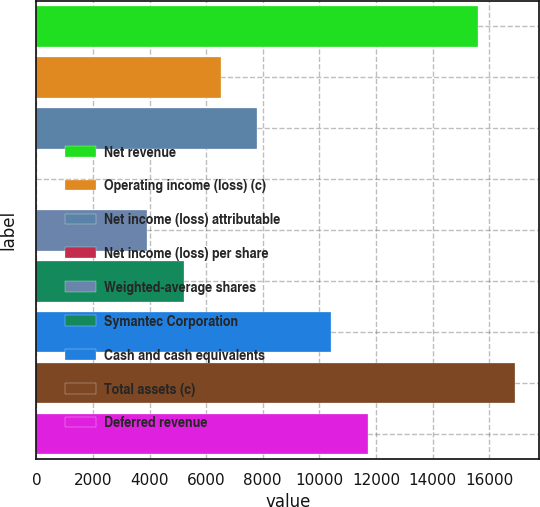Convert chart to OTSL. <chart><loc_0><loc_0><loc_500><loc_500><bar_chart><fcel>Net revenue<fcel>Operating income (loss) (c)<fcel>Net income (loss) attributable<fcel>Net income (loss) per share<fcel>Weighted-average shares<fcel>Symantec Corporation<fcel>Cash and cash equivalents<fcel>Total assets (c)<fcel>Deferred revenue<nl><fcel>15623.6<fcel>6510.77<fcel>7812.61<fcel>1.57<fcel>3907.09<fcel>5208.93<fcel>10416.3<fcel>16925.5<fcel>11718.1<nl></chart> 